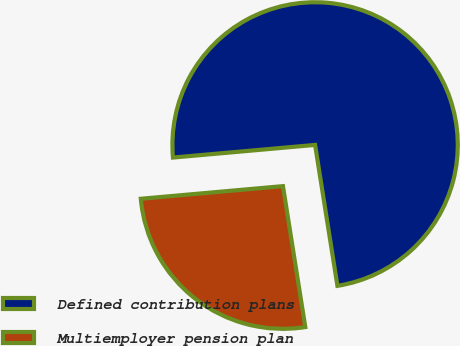Convert chart to OTSL. <chart><loc_0><loc_0><loc_500><loc_500><pie_chart><fcel>Defined contribution plans<fcel>Multiemployer pension plan<nl><fcel>73.91%<fcel>26.09%<nl></chart> 